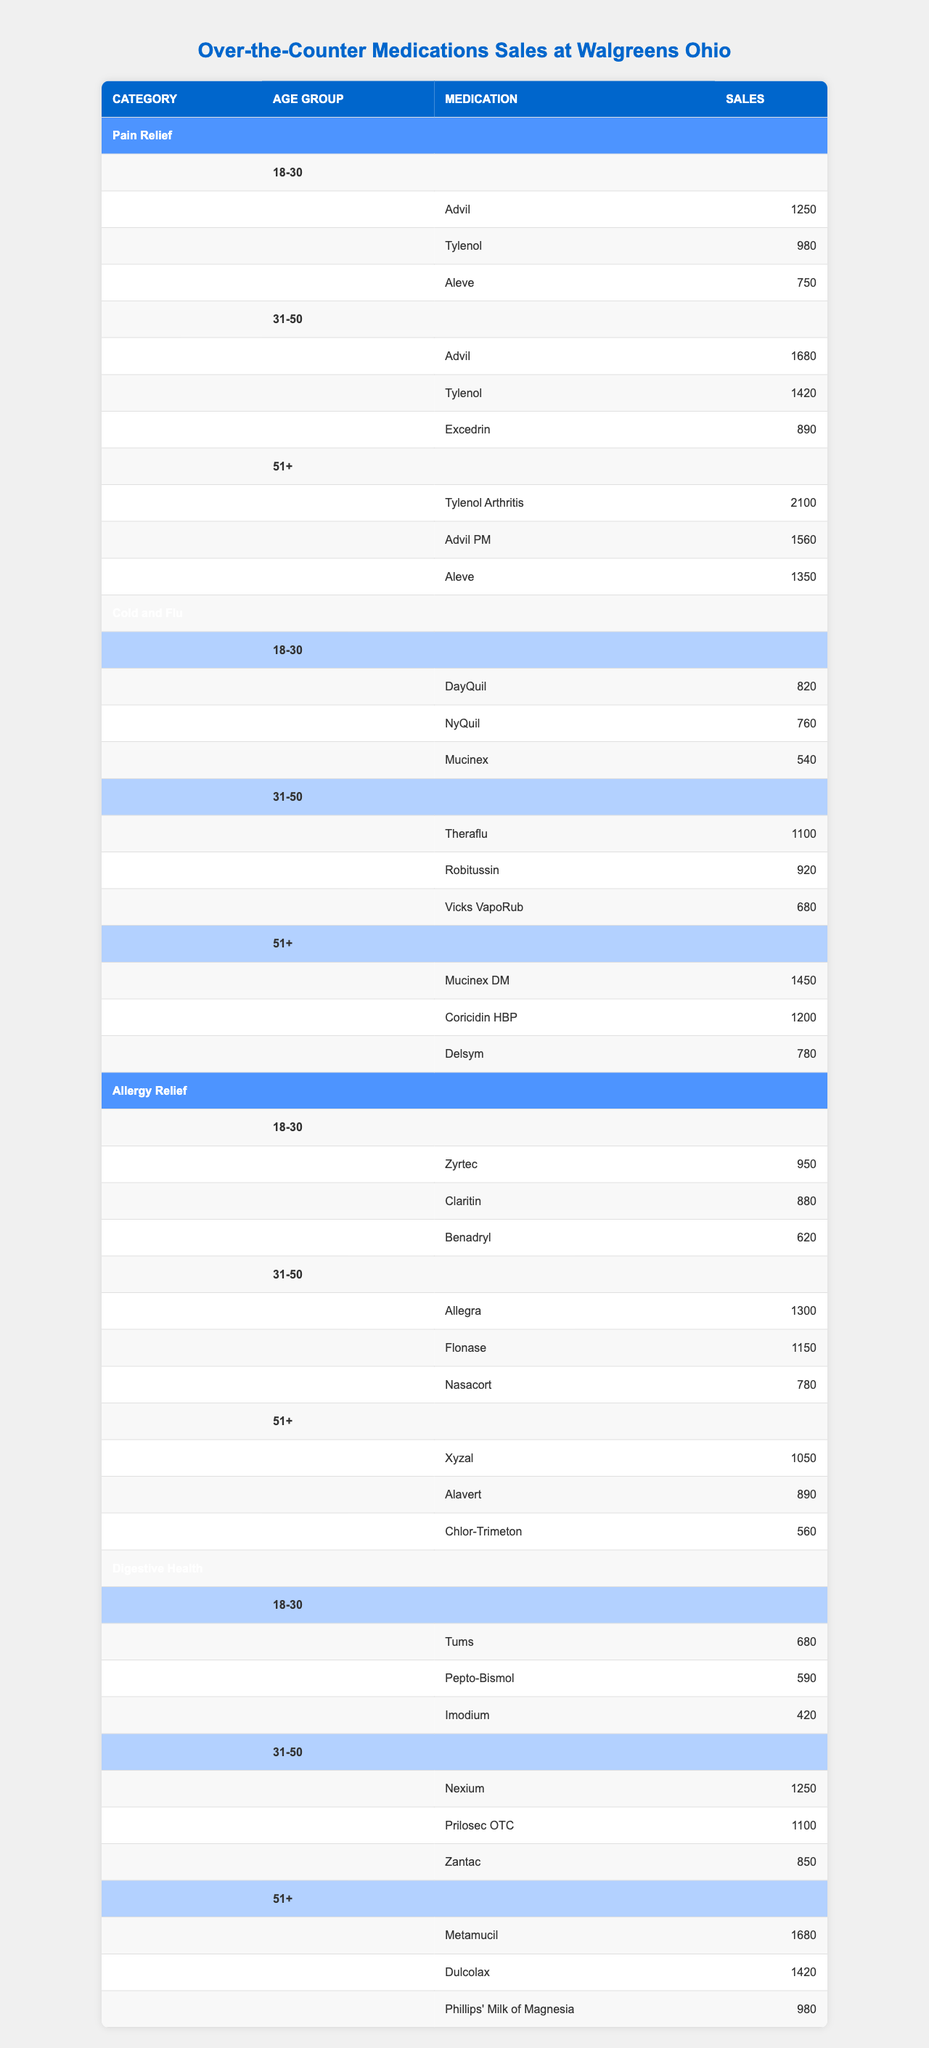What's the best-selling pain relief medication for the 51+ age group? The table shows that "Tylenol Arthritis" has the highest sales of 2100 units in the Pain Relief category for the 51+ age group.
Answer: Tylenol Arthritis Which cold and flu medication had the highest sales among 31-50-year-olds? According to the table, "Theraflu" had the highest sales at 1100 units in the Cold and Flu category for the 31-50 age group.
Answer: Theraflu In which age group is Aleve most popular according to the sales data? By reviewing the table, Aleve shows sales of 750 among 18-30, 790 among 31-50, and 1350 among 51+, indicating it is most popular among 51+ age group.
Answer: 51+ What's the combined sales of allergy relief medications for the 18-30 age group? The sales for the 18-30 age group are Zyrtec (950) + Claritin (880) + Benadryl (620). Summing these gives 950 + 880 + 620 = 2450.
Answer: 2450 Is Excedrin sold more than Aleve in the 31-50 age group? The table shows Excedrin's sales at 890 while Aleve's sales are 790, meaning Excedrin is sold more.
Answer: Yes Which age group collectively spends the least on cold and flu medications? For each group, the sales are: 18-30: 820 + 760 + 540 = 2120, 31-50: 1100 + 920 + 680 = 2700, 51+: 1450 + 1200 + 780 = 3430. Therefore, 18-30 has the least at 2120.
Answer: 18-30 How much more sales did Metamucil have compared to Imodium in their respective most sold age groups? Metamucil sales are 1680 (51+) while Imodium sales are 420 (18-30). The difference is 1680 - 420 = 1260.
Answer: 1260 What percentage of sales of pain relief medications does Tylenol account for in the 31-50 age group? In the 31-50 age group, total sales of pain relief medications = 1680 (Advil) + 1420 (Tylenol) + 890 (Excedrin) = 3990. Tylenol sales are 1420, so the percentage is (1420 / 3990) * 100 ≈ 35.6%.
Answer: 35.6% Among the digestive health category, which medication has the highest sales in the 51+ age group? The table indicates Metamucil with sales of 1680, which is the highest in the 51+ age group in the Digestive Health category.
Answer: Metamucil What is the total sales of all medications in the Allergy Relief category for age group 31-50? The medications sold are Allegra (1300), Flonase (1150), and Nasacort (780). Adding yields 1300 + 1150 + 780 = 3230.
Answer: 3230 